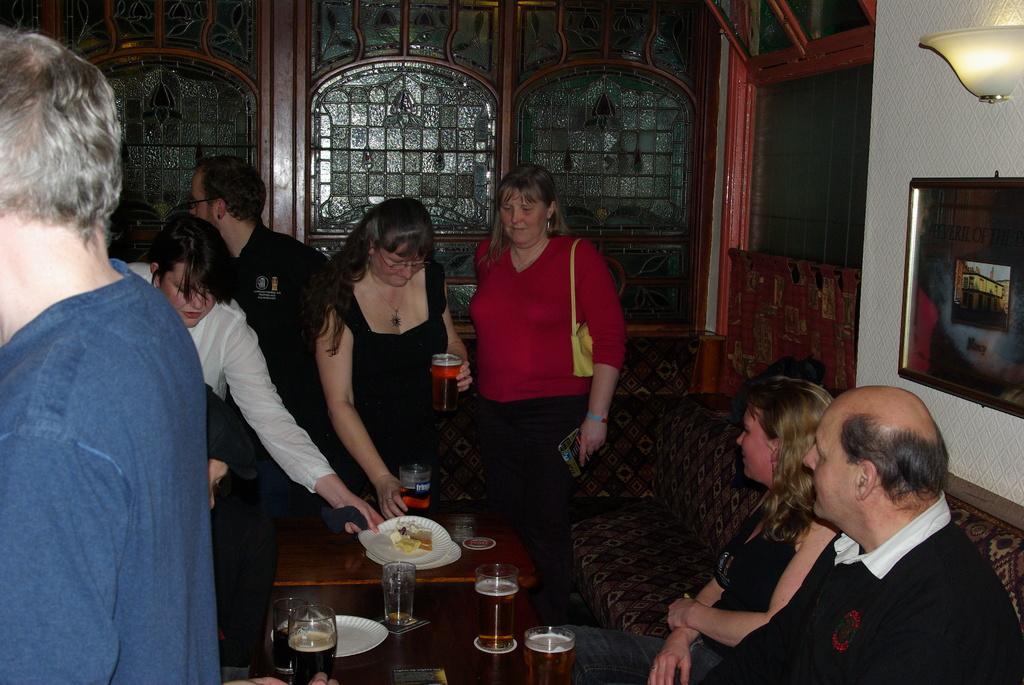Can you describe this image briefly? In picture there are many people standing and two people are sitting on the sofa table in front of them on the table there are plates glasses with a liquid on it on the wall there is a frame and a light a woman is carrying a handbag. 